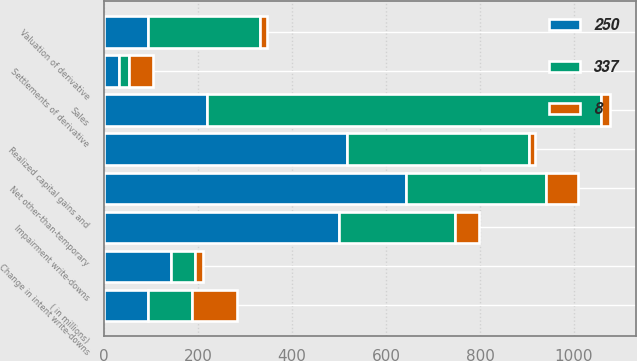<chart> <loc_0><loc_0><loc_500><loc_500><stacked_bar_chart><ecel><fcel>( in millions)<fcel>Impairment write-downs<fcel>Change in intent write-downs<fcel>Net other-than-temporary<fcel>Sales<fcel>Valuation of derivative<fcel>Settlements of derivative<fcel>Realized capital gains and<nl><fcel>8<fcel>94<fcel>51<fcel>17<fcel>68<fcel>20<fcel>16<fcel>51<fcel>13<nl><fcel>337<fcel>94<fcel>246<fcel>51<fcel>297<fcel>838<fcel>237<fcel>22<fcel>388<nl><fcel>250<fcel>94<fcel>501<fcel>142<fcel>643<fcel>219<fcel>94<fcel>31<fcel>517<nl></chart> 